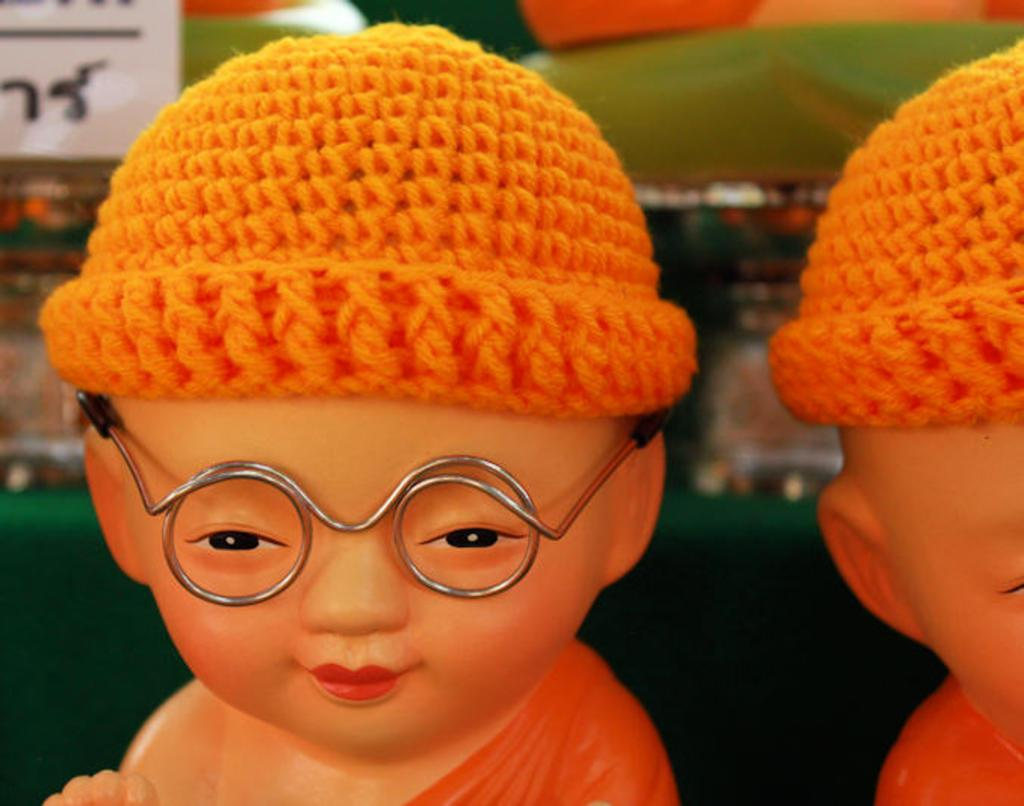What type of objects can be seen in the image? There are dolls in the image. What are the dolls wearing on their heads? The dolls are wearing woolen hats. Can you see any worms crawling on the dolls in the image? No, there are no worms present in the image. 